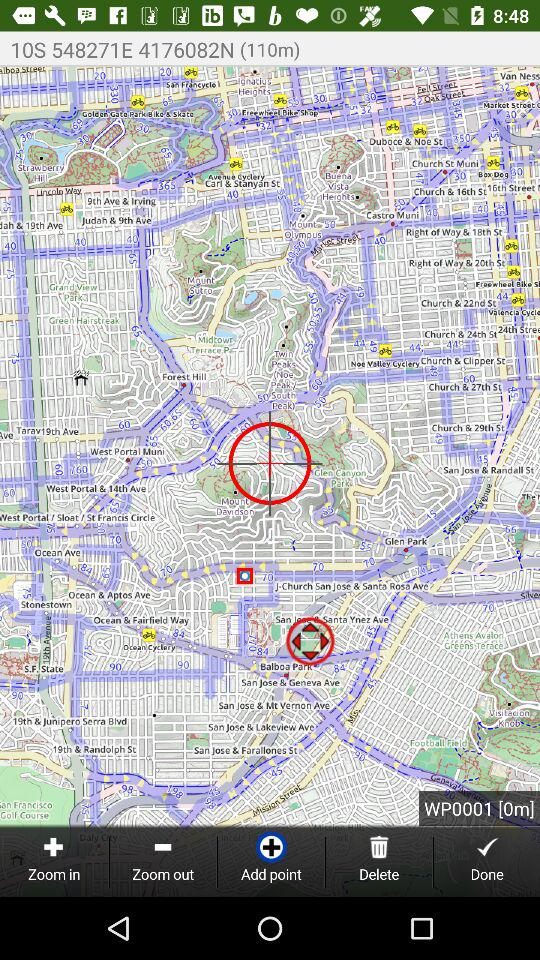How many waypoints are there?
Answer the question using a single word or phrase. 2 